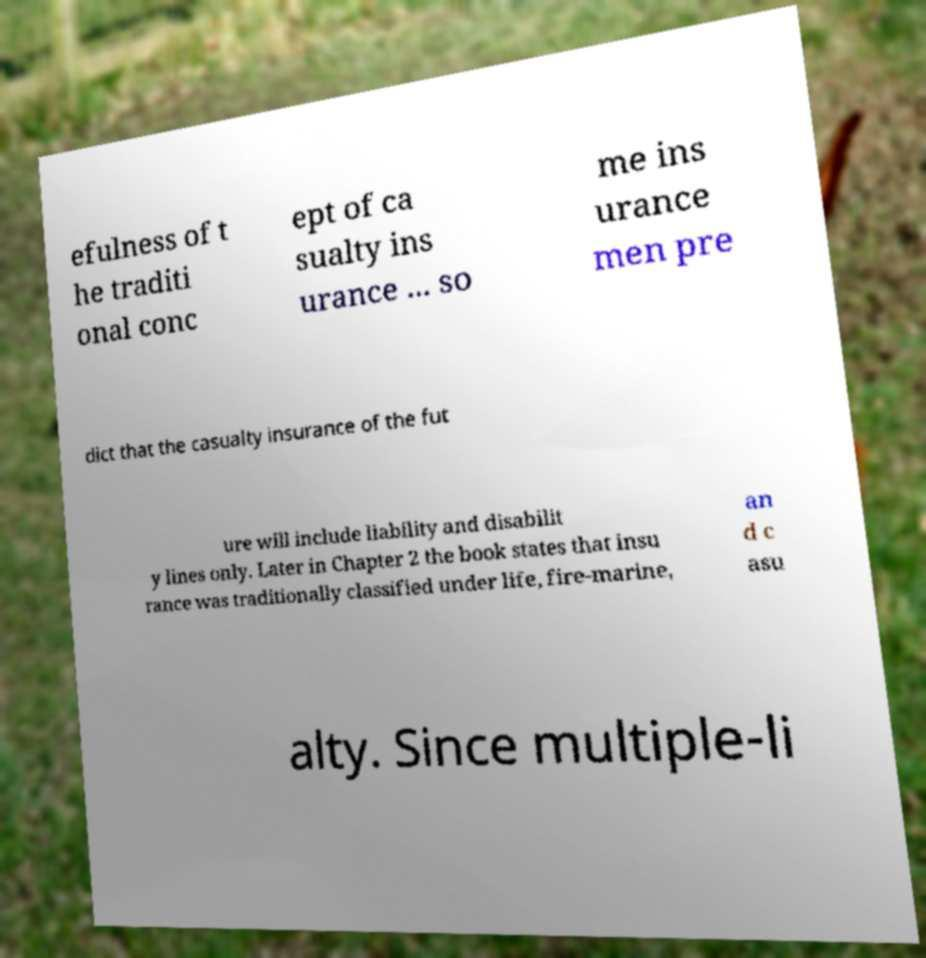Please read and relay the text visible in this image. What does it say? efulness of t he traditi onal conc ept of ca sualty ins urance ... so me ins urance men pre dict that the casualty insurance of the fut ure will include liability and disabilit y lines only. Later in Chapter 2 the book states that insu rance was traditionally classified under life, fire-marine, an d c asu alty. Since multiple-li 